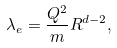Convert formula to latex. <formula><loc_0><loc_0><loc_500><loc_500>\lambda _ { e } = \frac { Q ^ { 2 } } { m } R ^ { d - 2 } ,</formula> 